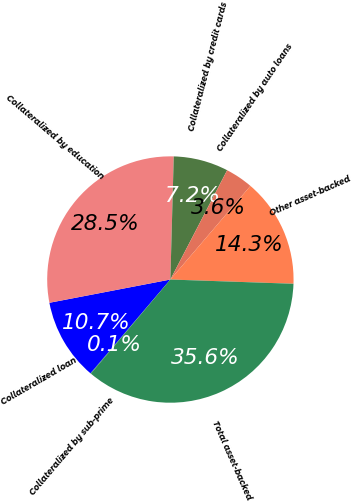Convert chart. <chart><loc_0><loc_0><loc_500><loc_500><pie_chart><fcel>Collateralized by sub-prime<fcel>Collateralized loan<fcel>Collateralized by education<fcel>Collateralized by credit cards<fcel>Collateralized by auto loans<fcel>Other asset-backed<fcel>Total asset-backed<nl><fcel>0.08%<fcel>10.74%<fcel>28.46%<fcel>7.19%<fcel>3.63%<fcel>14.29%<fcel>35.61%<nl></chart> 